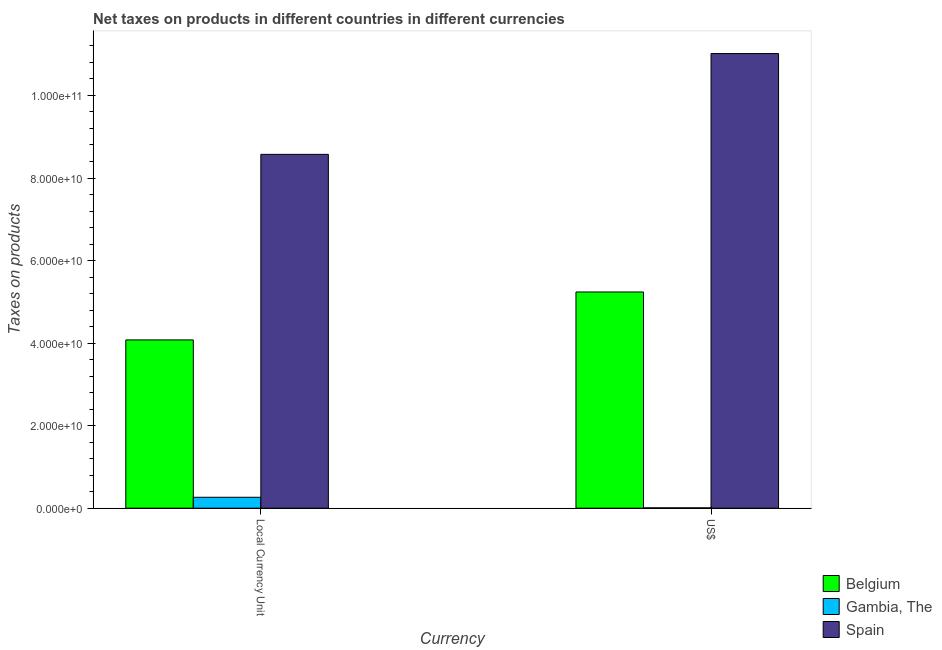Are the number of bars per tick equal to the number of legend labels?
Keep it short and to the point. Yes. Are the number of bars on each tick of the X-axis equal?
Your answer should be compact. Yes. How many bars are there on the 1st tick from the right?
Offer a very short reply. 3. What is the label of the 2nd group of bars from the left?
Ensure brevity in your answer.  US$. What is the net taxes in us$ in Gambia, The?
Your answer should be compact. 8.25e+07. Across all countries, what is the maximum net taxes in us$?
Your answer should be very brief. 1.10e+11. Across all countries, what is the minimum net taxes in constant 2005 us$?
Keep it short and to the point. 2.64e+09. In which country was the net taxes in us$ maximum?
Give a very brief answer. Spain. In which country was the net taxes in constant 2005 us$ minimum?
Ensure brevity in your answer.  Gambia, The. What is the total net taxes in us$ in the graph?
Provide a succinct answer. 1.63e+11. What is the difference between the net taxes in us$ in Belgium and that in Gambia, The?
Make the answer very short. 5.23e+1. What is the difference between the net taxes in constant 2005 us$ in Belgium and the net taxes in us$ in Spain?
Give a very brief answer. -6.94e+1. What is the average net taxes in us$ per country?
Ensure brevity in your answer.  5.42e+1. What is the difference between the net taxes in us$ and net taxes in constant 2005 us$ in Belgium?
Offer a terse response. 1.16e+1. In how many countries, is the net taxes in constant 2005 us$ greater than 8000000000 units?
Your answer should be compact. 2. What is the ratio of the net taxes in constant 2005 us$ in Belgium to that in Gambia, The?
Your answer should be very brief. 15.42. In how many countries, is the net taxes in constant 2005 us$ greater than the average net taxes in constant 2005 us$ taken over all countries?
Your answer should be very brief. 1. What does the 2nd bar from the left in Local Currency Unit represents?
Ensure brevity in your answer.  Gambia, The. What does the 2nd bar from the right in US$ represents?
Give a very brief answer. Gambia, The. How many bars are there?
Offer a terse response. 6. Are all the bars in the graph horizontal?
Provide a succinct answer. No. Are the values on the major ticks of Y-axis written in scientific E-notation?
Offer a very short reply. Yes. Does the graph contain grids?
Offer a terse response. No. How many legend labels are there?
Offer a terse response. 3. How are the legend labels stacked?
Offer a terse response. Vertical. What is the title of the graph?
Your answer should be compact. Net taxes on products in different countries in different currencies. What is the label or title of the X-axis?
Ensure brevity in your answer.  Currency. What is the label or title of the Y-axis?
Provide a succinct answer. Taxes on products. What is the Taxes on products in Belgium in Local Currency Unit?
Your answer should be very brief. 4.08e+1. What is the Taxes on products of Gambia, The in Local Currency Unit?
Offer a terse response. 2.64e+09. What is the Taxes on products in Spain in Local Currency Unit?
Keep it short and to the point. 8.57e+1. What is the Taxes on products in Belgium in US$?
Your answer should be compact. 5.24e+1. What is the Taxes on products in Gambia, The in US$?
Your answer should be very brief. 8.25e+07. What is the Taxes on products in Spain in US$?
Keep it short and to the point. 1.10e+11. Across all Currency, what is the maximum Taxes on products in Belgium?
Keep it short and to the point. 5.24e+1. Across all Currency, what is the maximum Taxes on products of Gambia, The?
Make the answer very short. 2.64e+09. Across all Currency, what is the maximum Taxes on products of Spain?
Ensure brevity in your answer.  1.10e+11. Across all Currency, what is the minimum Taxes on products of Belgium?
Your answer should be very brief. 4.08e+1. Across all Currency, what is the minimum Taxes on products in Gambia, The?
Your response must be concise. 8.25e+07. Across all Currency, what is the minimum Taxes on products in Spain?
Your answer should be compact. 8.57e+1. What is the total Taxes on products in Belgium in the graph?
Offer a terse response. 9.32e+1. What is the total Taxes on products in Gambia, The in the graph?
Make the answer very short. 2.73e+09. What is the total Taxes on products of Spain in the graph?
Make the answer very short. 1.96e+11. What is the difference between the Taxes on products of Belgium in Local Currency Unit and that in US$?
Keep it short and to the point. -1.16e+1. What is the difference between the Taxes on products in Gambia, The in Local Currency Unit and that in US$?
Your answer should be very brief. 2.56e+09. What is the difference between the Taxes on products in Spain in Local Currency Unit and that in US$?
Provide a short and direct response. -2.44e+1. What is the difference between the Taxes on products in Belgium in Local Currency Unit and the Taxes on products in Gambia, The in US$?
Ensure brevity in your answer.  4.07e+1. What is the difference between the Taxes on products in Belgium in Local Currency Unit and the Taxes on products in Spain in US$?
Your response must be concise. -6.94e+1. What is the difference between the Taxes on products of Gambia, The in Local Currency Unit and the Taxes on products of Spain in US$?
Provide a short and direct response. -1.08e+11. What is the average Taxes on products in Belgium per Currency?
Give a very brief answer. 4.66e+1. What is the average Taxes on products of Gambia, The per Currency?
Provide a succinct answer. 1.36e+09. What is the average Taxes on products in Spain per Currency?
Make the answer very short. 9.79e+1. What is the difference between the Taxes on products of Belgium and Taxes on products of Gambia, The in Local Currency Unit?
Offer a very short reply. 3.81e+1. What is the difference between the Taxes on products of Belgium and Taxes on products of Spain in Local Currency Unit?
Your answer should be very brief. -4.50e+1. What is the difference between the Taxes on products of Gambia, The and Taxes on products of Spain in Local Currency Unit?
Offer a very short reply. -8.31e+1. What is the difference between the Taxes on products in Belgium and Taxes on products in Gambia, The in US$?
Give a very brief answer. 5.23e+1. What is the difference between the Taxes on products of Belgium and Taxes on products of Spain in US$?
Your answer should be compact. -5.78e+1. What is the difference between the Taxes on products of Gambia, The and Taxes on products of Spain in US$?
Offer a terse response. -1.10e+11. What is the ratio of the Taxes on products of Belgium in Local Currency Unit to that in US$?
Make the answer very short. 0.78. What is the ratio of the Taxes on products of Gambia, The in Local Currency Unit to that in US$?
Your answer should be very brief. 32.08. What is the ratio of the Taxes on products of Spain in Local Currency Unit to that in US$?
Provide a succinct answer. 0.78. What is the difference between the highest and the second highest Taxes on products of Belgium?
Keep it short and to the point. 1.16e+1. What is the difference between the highest and the second highest Taxes on products in Gambia, The?
Give a very brief answer. 2.56e+09. What is the difference between the highest and the second highest Taxes on products in Spain?
Ensure brevity in your answer.  2.44e+1. What is the difference between the highest and the lowest Taxes on products in Belgium?
Keep it short and to the point. 1.16e+1. What is the difference between the highest and the lowest Taxes on products of Gambia, The?
Keep it short and to the point. 2.56e+09. What is the difference between the highest and the lowest Taxes on products in Spain?
Ensure brevity in your answer.  2.44e+1. 